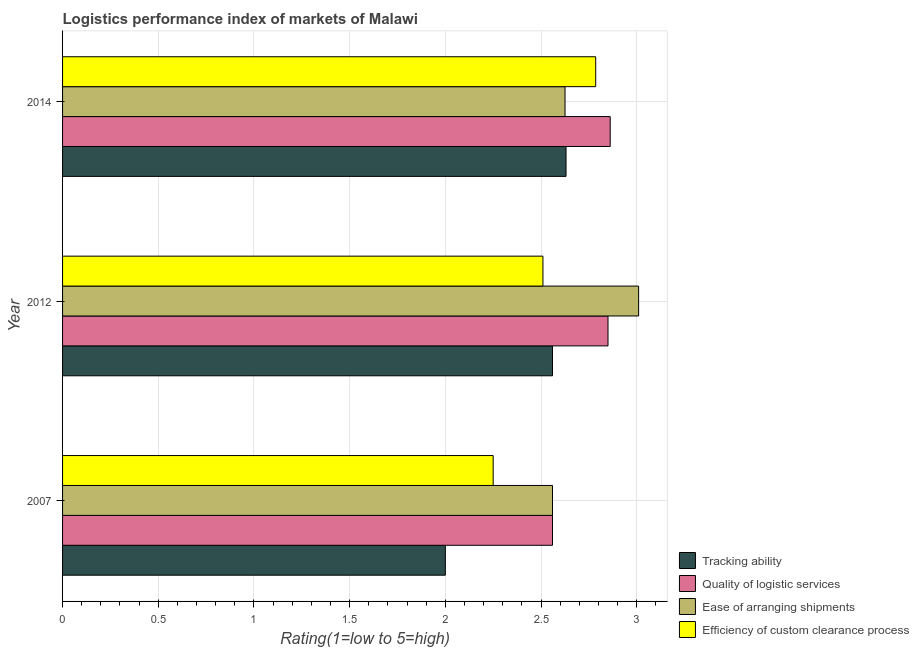How many different coloured bars are there?
Ensure brevity in your answer.  4. Are the number of bars on each tick of the Y-axis equal?
Your answer should be compact. Yes. What is the label of the 2nd group of bars from the top?
Provide a succinct answer. 2012. What is the lpi rating of tracking ability in 2012?
Provide a succinct answer. 2.56. Across all years, what is the maximum lpi rating of quality of logistic services?
Your answer should be very brief. 2.86. Across all years, what is the minimum lpi rating of efficiency of custom clearance process?
Offer a very short reply. 2.25. In which year was the lpi rating of quality of logistic services minimum?
Provide a succinct answer. 2007. What is the total lpi rating of quality of logistic services in the graph?
Offer a very short reply. 8.27. What is the difference between the lpi rating of ease of arranging shipments in 2007 and that in 2012?
Offer a very short reply. -0.45. What is the difference between the lpi rating of quality of logistic services in 2012 and the lpi rating of efficiency of custom clearance process in 2007?
Keep it short and to the point. 0.6. What is the average lpi rating of tracking ability per year?
Your answer should be compact. 2.4. In the year 2007, what is the difference between the lpi rating of tracking ability and lpi rating of quality of logistic services?
Make the answer very short. -0.56. What is the ratio of the lpi rating of tracking ability in 2007 to that in 2012?
Give a very brief answer. 0.78. Is the lpi rating of ease of arranging shipments in 2007 less than that in 2012?
Offer a terse response. Yes. What is the difference between the highest and the second highest lpi rating of quality of logistic services?
Make the answer very short. 0.01. What is the difference between the highest and the lowest lpi rating of ease of arranging shipments?
Provide a short and direct response. 0.45. In how many years, is the lpi rating of quality of logistic services greater than the average lpi rating of quality of logistic services taken over all years?
Keep it short and to the point. 2. Is the sum of the lpi rating of tracking ability in 2007 and 2012 greater than the maximum lpi rating of efficiency of custom clearance process across all years?
Offer a terse response. Yes. What does the 4th bar from the top in 2014 represents?
Offer a terse response. Tracking ability. What does the 1st bar from the bottom in 2014 represents?
Give a very brief answer. Tracking ability. Are all the bars in the graph horizontal?
Offer a very short reply. Yes. What is the difference between two consecutive major ticks on the X-axis?
Provide a short and direct response. 0.5. Where does the legend appear in the graph?
Make the answer very short. Bottom right. How are the legend labels stacked?
Keep it short and to the point. Vertical. What is the title of the graph?
Ensure brevity in your answer.  Logistics performance index of markets of Malawi. What is the label or title of the X-axis?
Make the answer very short. Rating(1=low to 5=high). What is the label or title of the Y-axis?
Your response must be concise. Year. What is the Rating(1=low to 5=high) of Quality of logistic services in 2007?
Offer a very short reply. 2.56. What is the Rating(1=low to 5=high) in Ease of arranging shipments in 2007?
Offer a very short reply. 2.56. What is the Rating(1=low to 5=high) in Efficiency of custom clearance process in 2007?
Keep it short and to the point. 2.25. What is the Rating(1=low to 5=high) in Tracking ability in 2012?
Ensure brevity in your answer.  2.56. What is the Rating(1=low to 5=high) in Quality of logistic services in 2012?
Provide a short and direct response. 2.85. What is the Rating(1=low to 5=high) of Ease of arranging shipments in 2012?
Ensure brevity in your answer.  3.01. What is the Rating(1=low to 5=high) in Efficiency of custom clearance process in 2012?
Offer a terse response. 2.51. What is the Rating(1=low to 5=high) in Tracking ability in 2014?
Offer a terse response. 2.63. What is the Rating(1=low to 5=high) in Quality of logistic services in 2014?
Provide a short and direct response. 2.86. What is the Rating(1=low to 5=high) of Ease of arranging shipments in 2014?
Offer a terse response. 2.63. What is the Rating(1=low to 5=high) in Efficiency of custom clearance process in 2014?
Keep it short and to the point. 2.79. Across all years, what is the maximum Rating(1=low to 5=high) in Tracking ability?
Provide a short and direct response. 2.63. Across all years, what is the maximum Rating(1=low to 5=high) of Quality of logistic services?
Ensure brevity in your answer.  2.86. Across all years, what is the maximum Rating(1=low to 5=high) in Ease of arranging shipments?
Your answer should be compact. 3.01. Across all years, what is the maximum Rating(1=low to 5=high) of Efficiency of custom clearance process?
Offer a terse response. 2.79. Across all years, what is the minimum Rating(1=low to 5=high) in Quality of logistic services?
Offer a very short reply. 2.56. Across all years, what is the minimum Rating(1=low to 5=high) of Ease of arranging shipments?
Your answer should be compact. 2.56. Across all years, what is the minimum Rating(1=low to 5=high) of Efficiency of custom clearance process?
Keep it short and to the point. 2.25. What is the total Rating(1=low to 5=high) in Tracking ability in the graph?
Ensure brevity in your answer.  7.19. What is the total Rating(1=low to 5=high) of Quality of logistic services in the graph?
Offer a terse response. 8.27. What is the total Rating(1=low to 5=high) in Ease of arranging shipments in the graph?
Your answer should be compact. 8.2. What is the total Rating(1=low to 5=high) of Efficiency of custom clearance process in the graph?
Ensure brevity in your answer.  7.55. What is the difference between the Rating(1=low to 5=high) of Tracking ability in 2007 and that in 2012?
Provide a succinct answer. -0.56. What is the difference between the Rating(1=low to 5=high) of Quality of logistic services in 2007 and that in 2012?
Keep it short and to the point. -0.29. What is the difference between the Rating(1=low to 5=high) of Ease of arranging shipments in 2007 and that in 2012?
Offer a very short reply. -0.45. What is the difference between the Rating(1=low to 5=high) of Efficiency of custom clearance process in 2007 and that in 2012?
Give a very brief answer. -0.26. What is the difference between the Rating(1=low to 5=high) of Tracking ability in 2007 and that in 2014?
Give a very brief answer. -0.63. What is the difference between the Rating(1=low to 5=high) of Quality of logistic services in 2007 and that in 2014?
Ensure brevity in your answer.  -0.3. What is the difference between the Rating(1=low to 5=high) in Ease of arranging shipments in 2007 and that in 2014?
Provide a short and direct response. -0.07. What is the difference between the Rating(1=low to 5=high) in Efficiency of custom clearance process in 2007 and that in 2014?
Make the answer very short. -0.54. What is the difference between the Rating(1=low to 5=high) of Tracking ability in 2012 and that in 2014?
Offer a very short reply. -0.07. What is the difference between the Rating(1=low to 5=high) of Quality of logistic services in 2012 and that in 2014?
Provide a succinct answer. -0.01. What is the difference between the Rating(1=low to 5=high) of Ease of arranging shipments in 2012 and that in 2014?
Offer a terse response. 0.38. What is the difference between the Rating(1=low to 5=high) in Efficiency of custom clearance process in 2012 and that in 2014?
Provide a short and direct response. -0.28. What is the difference between the Rating(1=low to 5=high) of Tracking ability in 2007 and the Rating(1=low to 5=high) of Quality of logistic services in 2012?
Keep it short and to the point. -0.85. What is the difference between the Rating(1=low to 5=high) in Tracking ability in 2007 and the Rating(1=low to 5=high) in Ease of arranging shipments in 2012?
Give a very brief answer. -1.01. What is the difference between the Rating(1=low to 5=high) of Tracking ability in 2007 and the Rating(1=low to 5=high) of Efficiency of custom clearance process in 2012?
Offer a very short reply. -0.51. What is the difference between the Rating(1=low to 5=high) in Quality of logistic services in 2007 and the Rating(1=low to 5=high) in Ease of arranging shipments in 2012?
Provide a succinct answer. -0.45. What is the difference between the Rating(1=low to 5=high) in Ease of arranging shipments in 2007 and the Rating(1=low to 5=high) in Efficiency of custom clearance process in 2012?
Ensure brevity in your answer.  0.05. What is the difference between the Rating(1=low to 5=high) of Tracking ability in 2007 and the Rating(1=low to 5=high) of Quality of logistic services in 2014?
Offer a terse response. -0.86. What is the difference between the Rating(1=low to 5=high) in Tracking ability in 2007 and the Rating(1=low to 5=high) in Ease of arranging shipments in 2014?
Keep it short and to the point. -0.63. What is the difference between the Rating(1=low to 5=high) in Tracking ability in 2007 and the Rating(1=low to 5=high) in Efficiency of custom clearance process in 2014?
Your response must be concise. -0.79. What is the difference between the Rating(1=low to 5=high) in Quality of logistic services in 2007 and the Rating(1=low to 5=high) in Ease of arranging shipments in 2014?
Provide a succinct answer. -0.07. What is the difference between the Rating(1=low to 5=high) in Quality of logistic services in 2007 and the Rating(1=low to 5=high) in Efficiency of custom clearance process in 2014?
Ensure brevity in your answer.  -0.23. What is the difference between the Rating(1=low to 5=high) in Ease of arranging shipments in 2007 and the Rating(1=low to 5=high) in Efficiency of custom clearance process in 2014?
Your response must be concise. -0.23. What is the difference between the Rating(1=low to 5=high) of Tracking ability in 2012 and the Rating(1=low to 5=high) of Quality of logistic services in 2014?
Offer a terse response. -0.3. What is the difference between the Rating(1=low to 5=high) in Tracking ability in 2012 and the Rating(1=low to 5=high) in Ease of arranging shipments in 2014?
Make the answer very short. -0.07. What is the difference between the Rating(1=low to 5=high) of Tracking ability in 2012 and the Rating(1=low to 5=high) of Efficiency of custom clearance process in 2014?
Ensure brevity in your answer.  -0.23. What is the difference between the Rating(1=low to 5=high) of Quality of logistic services in 2012 and the Rating(1=low to 5=high) of Ease of arranging shipments in 2014?
Your answer should be compact. 0.22. What is the difference between the Rating(1=low to 5=high) in Quality of logistic services in 2012 and the Rating(1=low to 5=high) in Efficiency of custom clearance process in 2014?
Provide a short and direct response. 0.06. What is the difference between the Rating(1=low to 5=high) of Ease of arranging shipments in 2012 and the Rating(1=low to 5=high) of Efficiency of custom clearance process in 2014?
Keep it short and to the point. 0.22. What is the average Rating(1=low to 5=high) of Tracking ability per year?
Offer a very short reply. 2.4. What is the average Rating(1=low to 5=high) in Quality of logistic services per year?
Offer a terse response. 2.76. What is the average Rating(1=low to 5=high) in Ease of arranging shipments per year?
Offer a terse response. 2.73. What is the average Rating(1=low to 5=high) of Efficiency of custom clearance process per year?
Provide a succinct answer. 2.52. In the year 2007, what is the difference between the Rating(1=low to 5=high) in Tracking ability and Rating(1=low to 5=high) in Quality of logistic services?
Offer a terse response. -0.56. In the year 2007, what is the difference between the Rating(1=low to 5=high) of Tracking ability and Rating(1=low to 5=high) of Ease of arranging shipments?
Offer a very short reply. -0.56. In the year 2007, what is the difference between the Rating(1=low to 5=high) of Tracking ability and Rating(1=low to 5=high) of Efficiency of custom clearance process?
Your answer should be very brief. -0.25. In the year 2007, what is the difference between the Rating(1=low to 5=high) of Quality of logistic services and Rating(1=low to 5=high) of Efficiency of custom clearance process?
Your answer should be compact. 0.31. In the year 2007, what is the difference between the Rating(1=low to 5=high) in Ease of arranging shipments and Rating(1=low to 5=high) in Efficiency of custom clearance process?
Provide a succinct answer. 0.31. In the year 2012, what is the difference between the Rating(1=low to 5=high) in Tracking ability and Rating(1=low to 5=high) in Quality of logistic services?
Your answer should be very brief. -0.29. In the year 2012, what is the difference between the Rating(1=low to 5=high) of Tracking ability and Rating(1=low to 5=high) of Ease of arranging shipments?
Make the answer very short. -0.45. In the year 2012, what is the difference between the Rating(1=low to 5=high) in Tracking ability and Rating(1=low to 5=high) in Efficiency of custom clearance process?
Keep it short and to the point. 0.05. In the year 2012, what is the difference between the Rating(1=low to 5=high) of Quality of logistic services and Rating(1=low to 5=high) of Ease of arranging shipments?
Ensure brevity in your answer.  -0.16. In the year 2012, what is the difference between the Rating(1=low to 5=high) in Quality of logistic services and Rating(1=low to 5=high) in Efficiency of custom clearance process?
Provide a succinct answer. 0.34. In the year 2014, what is the difference between the Rating(1=low to 5=high) in Tracking ability and Rating(1=low to 5=high) in Quality of logistic services?
Keep it short and to the point. -0.23. In the year 2014, what is the difference between the Rating(1=low to 5=high) in Tracking ability and Rating(1=low to 5=high) in Ease of arranging shipments?
Offer a terse response. 0.01. In the year 2014, what is the difference between the Rating(1=low to 5=high) of Tracking ability and Rating(1=low to 5=high) of Efficiency of custom clearance process?
Your answer should be very brief. -0.15. In the year 2014, what is the difference between the Rating(1=low to 5=high) of Quality of logistic services and Rating(1=low to 5=high) of Ease of arranging shipments?
Offer a very short reply. 0.24. In the year 2014, what is the difference between the Rating(1=low to 5=high) in Quality of logistic services and Rating(1=low to 5=high) in Efficiency of custom clearance process?
Keep it short and to the point. 0.08. In the year 2014, what is the difference between the Rating(1=low to 5=high) of Ease of arranging shipments and Rating(1=low to 5=high) of Efficiency of custom clearance process?
Keep it short and to the point. -0.16. What is the ratio of the Rating(1=low to 5=high) in Tracking ability in 2007 to that in 2012?
Give a very brief answer. 0.78. What is the ratio of the Rating(1=low to 5=high) in Quality of logistic services in 2007 to that in 2012?
Your answer should be very brief. 0.9. What is the ratio of the Rating(1=low to 5=high) in Ease of arranging shipments in 2007 to that in 2012?
Offer a terse response. 0.85. What is the ratio of the Rating(1=low to 5=high) of Efficiency of custom clearance process in 2007 to that in 2012?
Keep it short and to the point. 0.9. What is the ratio of the Rating(1=low to 5=high) of Tracking ability in 2007 to that in 2014?
Offer a very short reply. 0.76. What is the ratio of the Rating(1=low to 5=high) of Quality of logistic services in 2007 to that in 2014?
Offer a terse response. 0.89. What is the ratio of the Rating(1=low to 5=high) in Ease of arranging shipments in 2007 to that in 2014?
Your answer should be compact. 0.98. What is the ratio of the Rating(1=low to 5=high) in Efficiency of custom clearance process in 2007 to that in 2014?
Offer a terse response. 0.81. What is the ratio of the Rating(1=low to 5=high) in Tracking ability in 2012 to that in 2014?
Your answer should be very brief. 0.97. What is the ratio of the Rating(1=low to 5=high) in Quality of logistic services in 2012 to that in 2014?
Your answer should be very brief. 1. What is the ratio of the Rating(1=low to 5=high) in Ease of arranging shipments in 2012 to that in 2014?
Provide a short and direct response. 1.15. What is the ratio of the Rating(1=low to 5=high) in Efficiency of custom clearance process in 2012 to that in 2014?
Give a very brief answer. 0.9. What is the difference between the highest and the second highest Rating(1=low to 5=high) of Tracking ability?
Offer a very short reply. 0.07. What is the difference between the highest and the second highest Rating(1=low to 5=high) in Quality of logistic services?
Your response must be concise. 0.01. What is the difference between the highest and the second highest Rating(1=low to 5=high) in Ease of arranging shipments?
Ensure brevity in your answer.  0.38. What is the difference between the highest and the second highest Rating(1=low to 5=high) of Efficiency of custom clearance process?
Your response must be concise. 0.28. What is the difference between the highest and the lowest Rating(1=low to 5=high) of Tracking ability?
Your answer should be compact. 0.63. What is the difference between the highest and the lowest Rating(1=low to 5=high) in Quality of logistic services?
Make the answer very short. 0.3. What is the difference between the highest and the lowest Rating(1=low to 5=high) of Ease of arranging shipments?
Your answer should be very brief. 0.45. What is the difference between the highest and the lowest Rating(1=low to 5=high) of Efficiency of custom clearance process?
Ensure brevity in your answer.  0.54. 